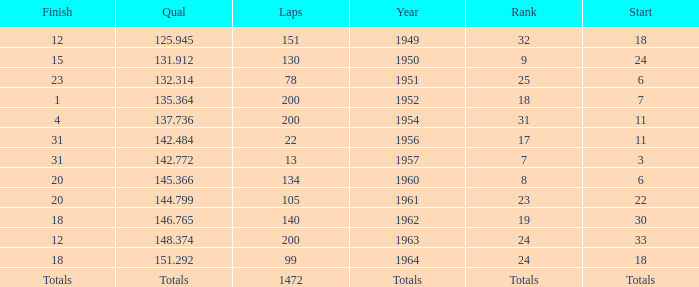Name the year for laps of 200 and rank of 24 1963.0. 